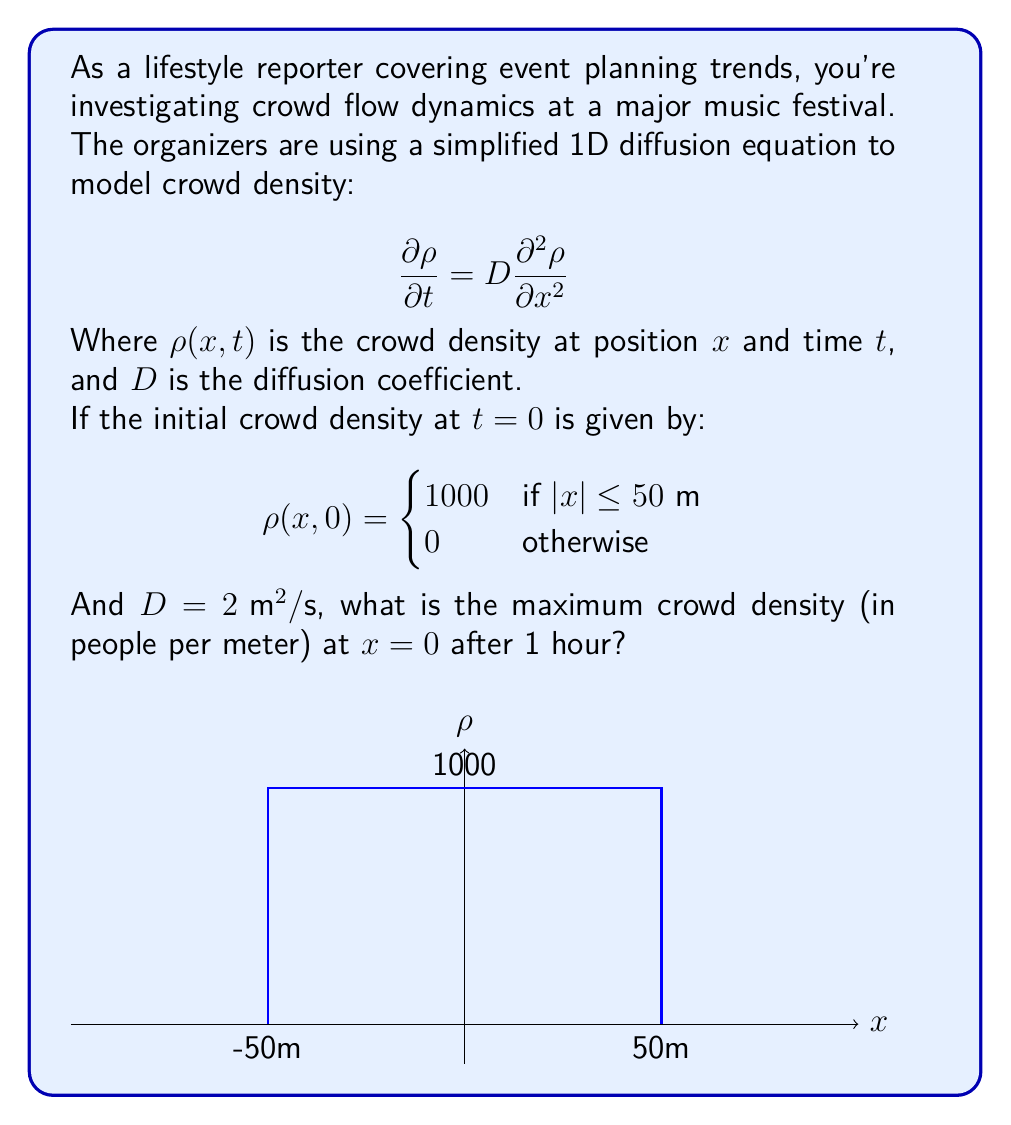What is the answer to this math problem? To solve this problem, we'll follow these steps:

1) The solution to the 1D diffusion equation with the given initial condition is:

   $$\rho(x,t) = \frac{500}{\sqrt{\pi Dt}} \left[ \text{erf}\left(\frac{50+x}{2\sqrt{Dt}}\right) + \text{erf}\left(\frac{50-x}{2\sqrt{Dt}}\right) \right]$$

   Where $\text{erf}$ is the error function.

2) We're interested in the density at $x=0$ after 1 hour. Let's substitute these values:
   
   $t = 3600 \text{ s}$ (1 hour)
   $x = 0 \text{ m}$
   $D = 2 \text{ m}^2/\text{s}$

3) Substituting into our equation:

   $$\rho(0,3600) = \frac{500}{\sqrt{\pi \cdot 2 \cdot 3600}} \left[ \text{erf}\left(\frac{50}{2\sqrt{2 \cdot 3600}}\right) + \text{erf}\left(\frac{50}{2\sqrt{2 \cdot 3600}}\right) \right]$$

4) Simplify:
   
   $$\rho(0,3600) = \frac{500}{\sqrt{7200\pi}} \cdot 2 \cdot \text{erf}\left(\frac{50}{120}\right)$$

5) Calculate:
   
   $$\rho(0,3600) \approx 70.71 \cdot 2 \cdot 0.4132 \approx 58.46$$

Therefore, the maximum crowd density at $x=0$ after 1 hour is approximately 58.46 people per meter.
Answer: 58.46 people/m 